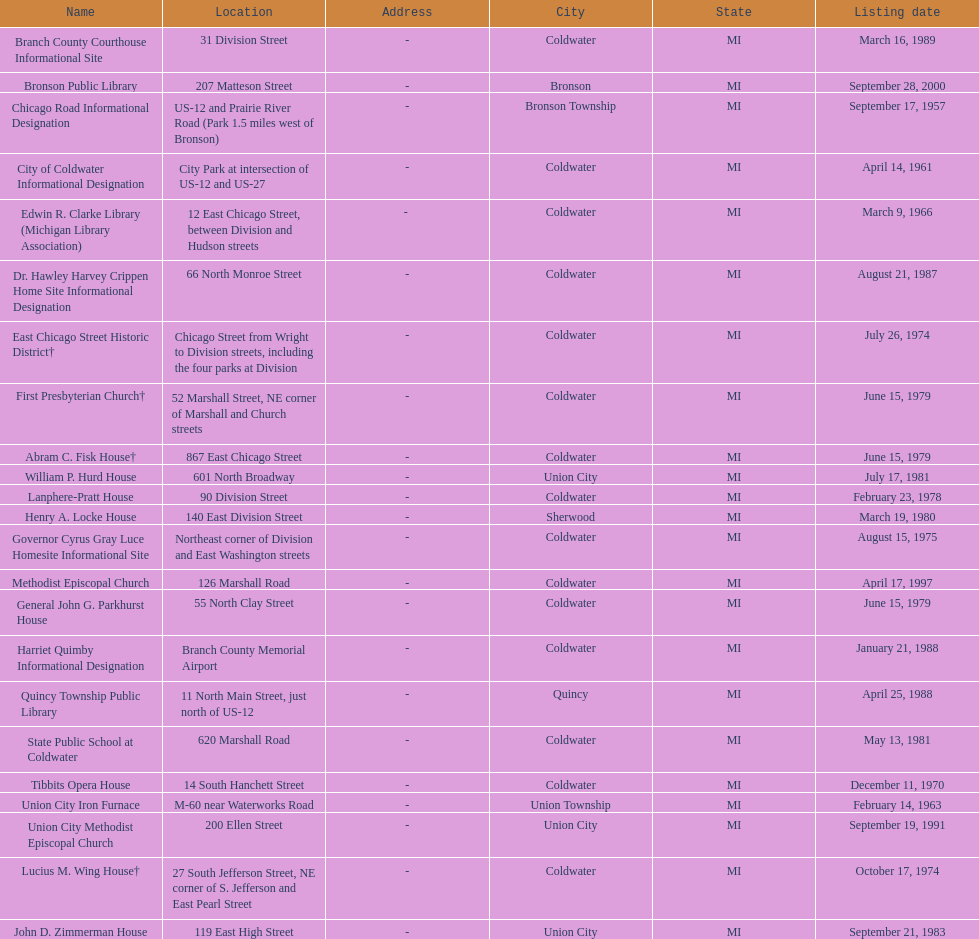How many historic sites were listed in 1988? 2. 